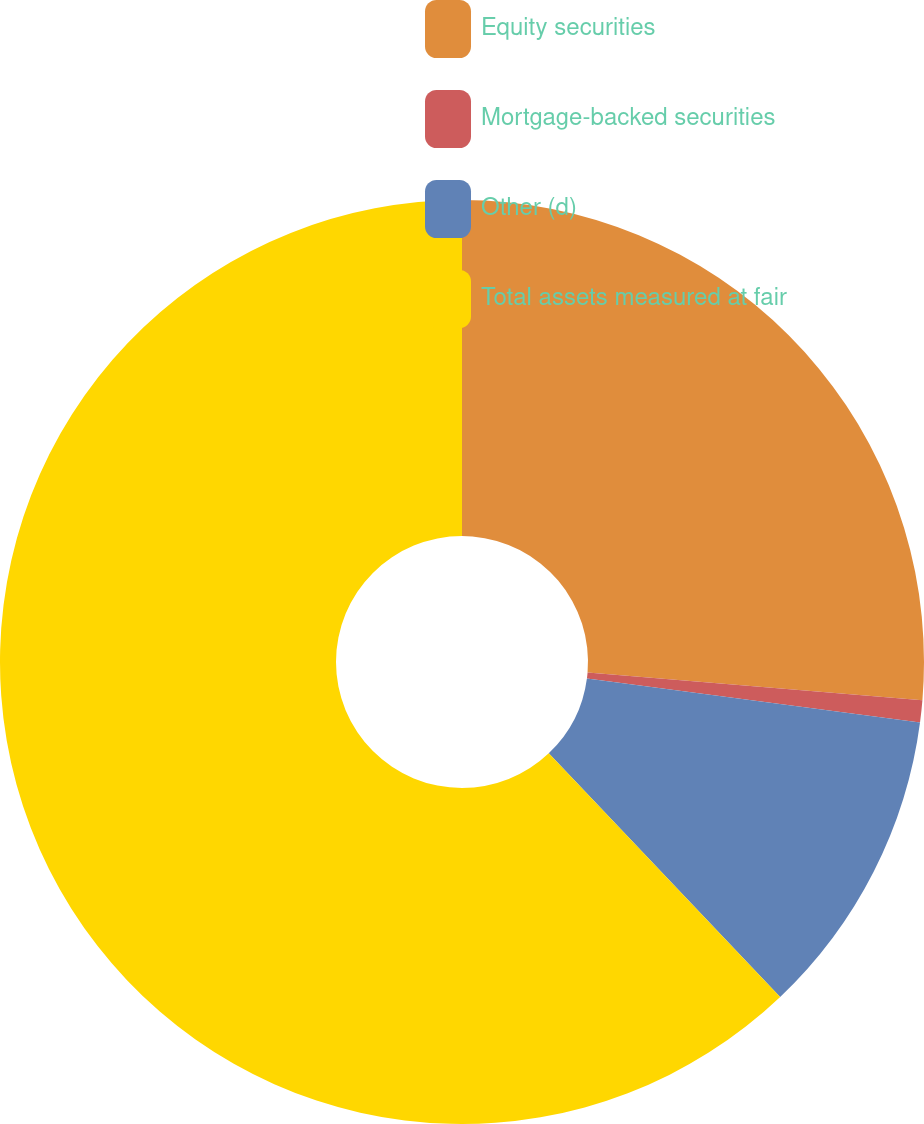<chart> <loc_0><loc_0><loc_500><loc_500><pie_chart><fcel>Equity securities<fcel>Mortgage-backed securities<fcel>Other (d)<fcel>Total assets measured at fair<nl><fcel>26.32%<fcel>0.77%<fcel>10.82%<fcel>62.09%<nl></chart> 